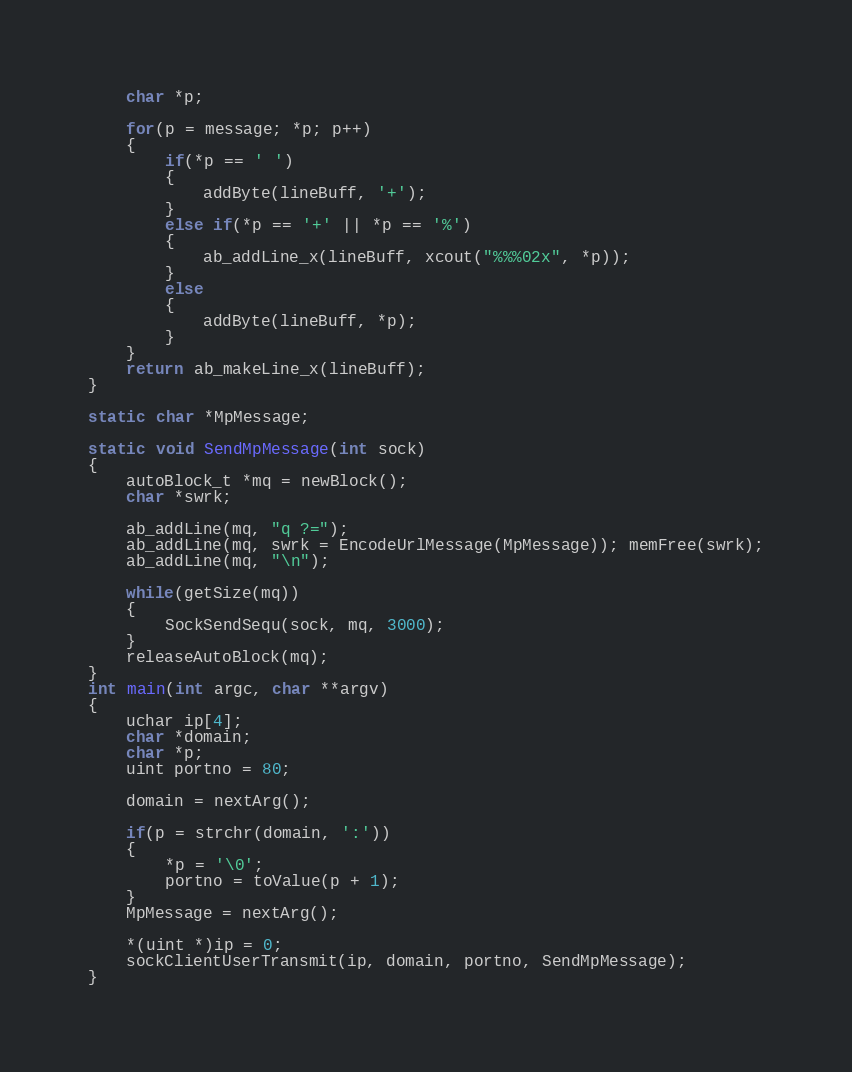<code> <loc_0><loc_0><loc_500><loc_500><_C_>	char *p;

	for(p = message; *p; p++)
	{
		if(*p == ' ')
		{
			addByte(lineBuff, '+');
		}
		else if(*p == '+' || *p == '%')
		{
			ab_addLine_x(lineBuff, xcout("%%%02x", *p));
		}
		else
		{
			addByte(lineBuff, *p);
		}
	}
	return ab_makeLine_x(lineBuff);
}

static char *MpMessage;

static void SendMpMessage(int sock)
{
	autoBlock_t *mq = newBlock();
	char *swrk;

	ab_addLine(mq, "q ?=");
	ab_addLine(mq, swrk = EncodeUrlMessage(MpMessage)); memFree(swrk);
	ab_addLine(mq, "\n");

	while(getSize(mq))
	{
		SockSendSequ(sock, mq, 3000);
	}
	releaseAutoBlock(mq);
}
int main(int argc, char **argv)
{
	uchar ip[4];
	char *domain;
	char *p;
	uint portno = 80;

	domain = nextArg();

	if(p = strchr(domain, ':'))
	{
		*p = '\0';
		portno = toValue(p + 1);
	}
	MpMessage = nextArg();

	*(uint *)ip = 0;
	sockClientUserTransmit(ip, domain, portno, SendMpMessage);
}
</code> 